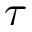<formula> <loc_0><loc_0><loc_500><loc_500>\tau</formula> 